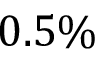Convert formula to latex. <formula><loc_0><loc_0><loc_500><loc_500>0 . 5 \%</formula> 